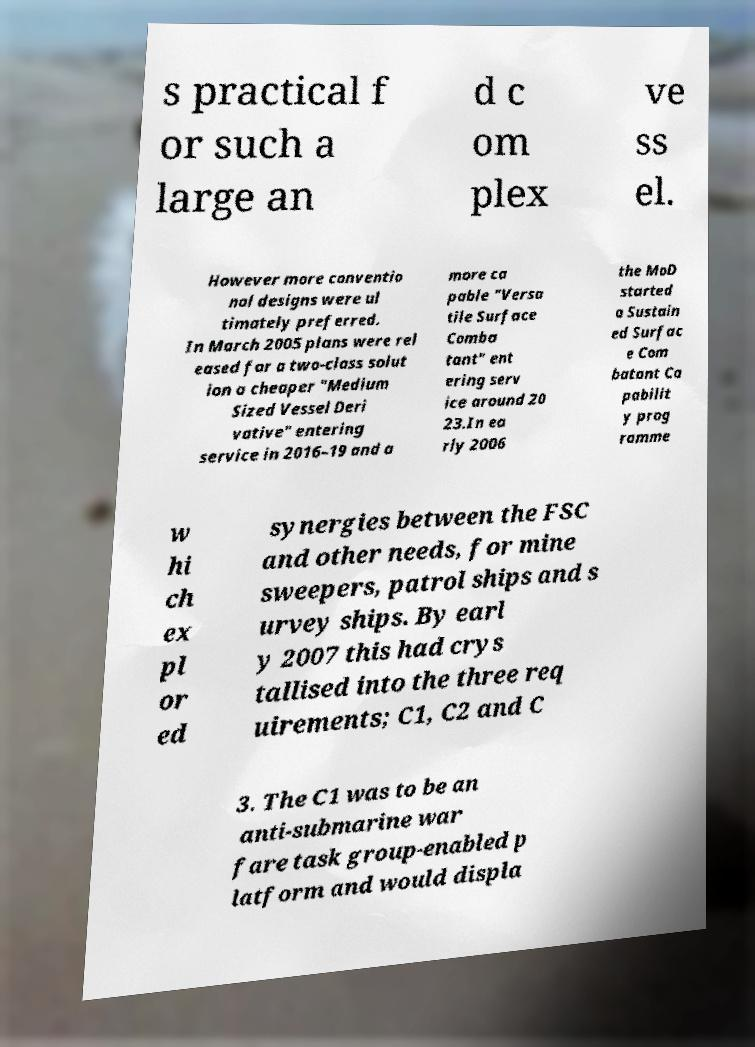Please identify and transcribe the text found in this image. s practical f or such a large an d c om plex ve ss el. However more conventio nal designs were ul timately preferred. In March 2005 plans were rel eased for a two-class solut ion a cheaper "Medium Sized Vessel Deri vative" entering service in 2016–19 and a more ca pable "Versa tile Surface Comba tant" ent ering serv ice around 20 23.In ea rly 2006 the MoD started a Sustain ed Surfac e Com batant Ca pabilit y prog ramme w hi ch ex pl or ed synergies between the FSC and other needs, for mine sweepers, patrol ships and s urvey ships. By earl y 2007 this had crys tallised into the three req uirements; C1, C2 and C 3. The C1 was to be an anti-submarine war fare task group-enabled p latform and would displa 